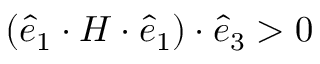<formula> <loc_0><loc_0><loc_500><loc_500>( \hat { e } _ { 1 } \cdot H \cdot \hat { e } _ { 1 } ) \cdot \hat { e } _ { 3 } > 0</formula> 